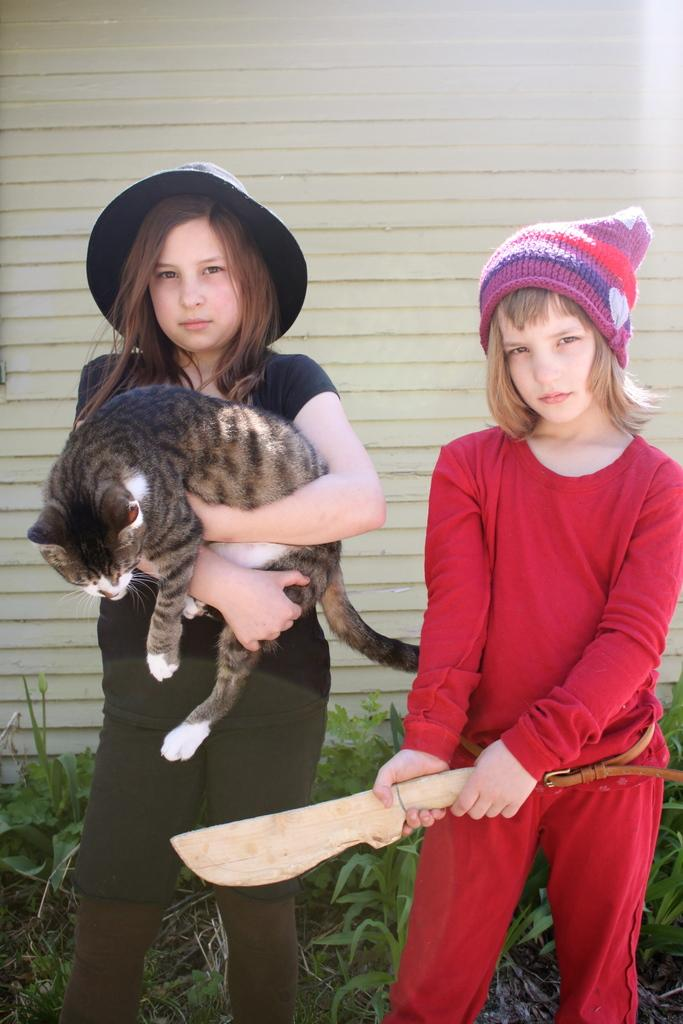How many people are present in the image? There are two people standing in the image. What is one person holding in her hand? One person is holding a cat in her hand. What is the girl holding in her hand? The girl is holding a knife in her hand. What can be seen in the background of the image? There is a wall visible in the image. How many lizards are crawling on the bucket in the image? There is no bucket or lizards present in the image. 